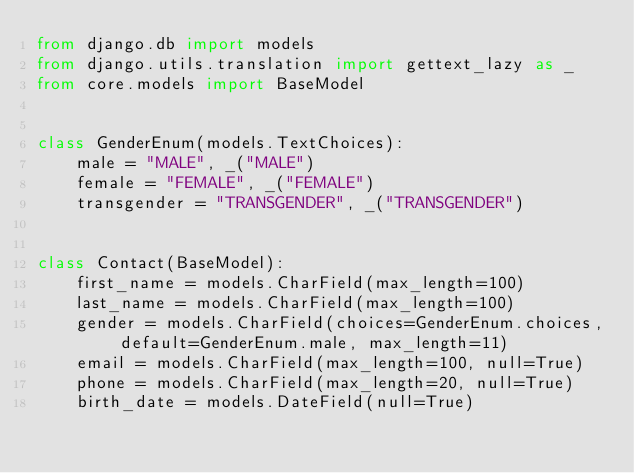Convert code to text. <code><loc_0><loc_0><loc_500><loc_500><_Python_>from django.db import models
from django.utils.translation import gettext_lazy as _
from core.models import BaseModel


class GenderEnum(models.TextChoices):
    male = "MALE", _("MALE")
    female = "FEMALE", _("FEMALE")
    transgender = "TRANSGENDER", _("TRANSGENDER")


class Contact(BaseModel):
    first_name = models.CharField(max_length=100)
    last_name = models.CharField(max_length=100)
    gender = models.CharField(choices=GenderEnum.choices, default=GenderEnum.male, max_length=11)
    email = models.CharField(max_length=100, null=True)
    phone = models.CharField(max_length=20, null=True)
    birth_date = models.DateField(null=True)
</code> 